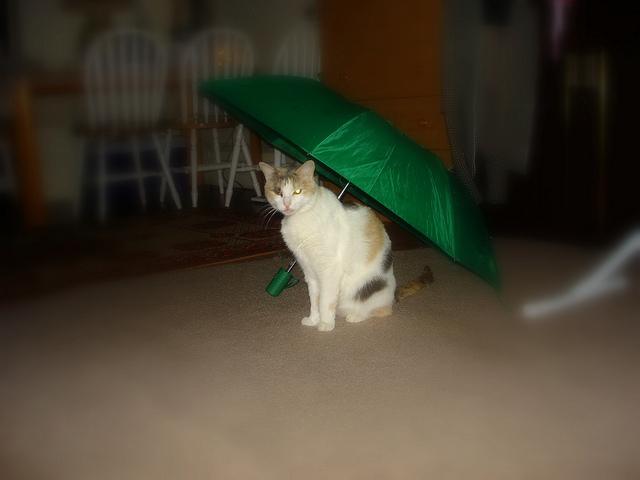What is the cat standing on?
Be succinct. Carpet. What style floor?
Be succinct. Carpet. What color is the floor?
Short answer required. Brown. How many spots can be seen on the cat?
Short answer required. 4. What is the car lying under?
Be succinct. Umbrella. Can you see the cat's reflection?
Give a very brief answer. No. Color of umbrella?
Short answer required. Green. 